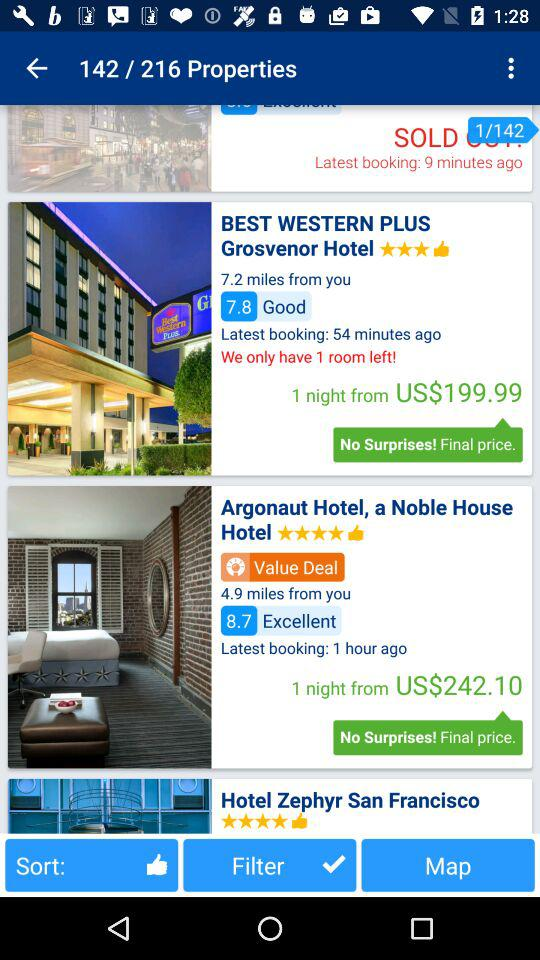How many dollars do you spend for one night in the Argonaut hotel, a noble house? We spent US$242.10 for one night. 